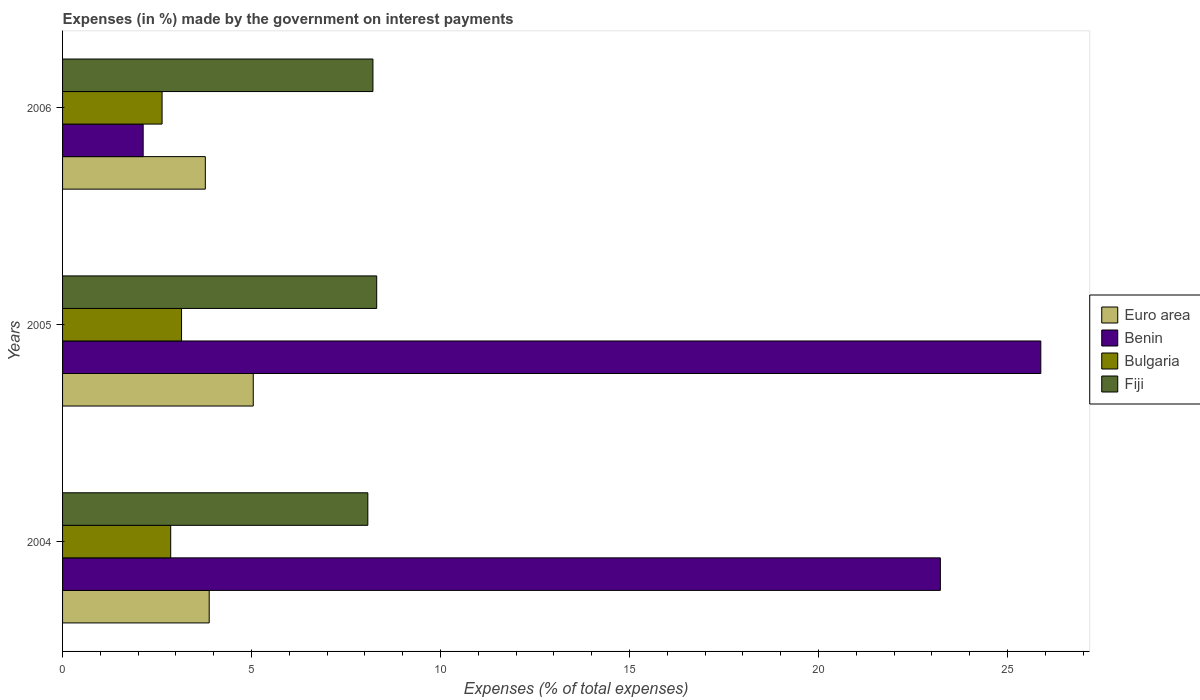How many different coloured bars are there?
Make the answer very short. 4. Are the number of bars per tick equal to the number of legend labels?
Give a very brief answer. Yes. Are the number of bars on each tick of the Y-axis equal?
Your answer should be very brief. Yes. In how many cases, is the number of bars for a given year not equal to the number of legend labels?
Make the answer very short. 0. What is the percentage of expenses made by the government on interest payments in Euro area in 2004?
Offer a terse response. 3.88. Across all years, what is the maximum percentage of expenses made by the government on interest payments in Benin?
Provide a short and direct response. 25.88. Across all years, what is the minimum percentage of expenses made by the government on interest payments in Fiji?
Offer a terse response. 8.08. What is the total percentage of expenses made by the government on interest payments in Bulgaria in the graph?
Keep it short and to the point. 8.64. What is the difference between the percentage of expenses made by the government on interest payments in Fiji in 2004 and that in 2005?
Provide a succinct answer. -0.23. What is the difference between the percentage of expenses made by the government on interest payments in Bulgaria in 2004 and the percentage of expenses made by the government on interest payments in Benin in 2006?
Provide a succinct answer. 0.73. What is the average percentage of expenses made by the government on interest payments in Euro area per year?
Your answer should be compact. 4.23. In the year 2005, what is the difference between the percentage of expenses made by the government on interest payments in Euro area and percentage of expenses made by the government on interest payments in Benin?
Make the answer very short. -20.84. In how many years, is the percentage of expenses made by the government on interest payments in Fiji greater than 4 %?
Offer a very short reply. 3. What is the ratio of the percentage of expenses made by the government on interest payments in Fiji in 2004 to that in 2005?
Provide a short and direct response. 0.97. Is the percentage of expenses made by the government on interest payments in Benin in 2005 less than that in 2006?
Ensure brevity in your answer.  No. What is the difference between the highest and the second highest percentage of expenses made by the government on interest payments in Fiji?
Make the answer very short. 0.1. What is the difference between the highest and the lowest percentage of expenses made by the government on interest payments in Euro area?
Your response must be concise. 1.27. In how many years, is the percentage of expenses made by the government on interest payments in Euro area greater than the average percentage of expenses made by the government on interest payments in Euro area taken over all years?
Provide a succinct answer. 1. Is the sum of the percentage of expenses made by the government on interest payments in Benin in 2005 and 2006 greater than the maximum percentage of expenses made by the government on interest payments in Euro area across all years?
Provide a short and direct response. Yes. Is it the case that in every year, the sum of the percentage of expenses made by the government on interest payments in Bulgaria and percentage of expenses made by the government on interest payments in Euro area is greater than the sum of percentage of expenses made by the government on interest payments in Fiji and percentage of expenses made by the government on interest payments in Benin?
Provide a short and direct response. No. What does the 1st bar from the top in 2004 represents?
Provide a succinct answer. Fiji. What does the 2nd bar from the bottom in 2004 represents?
Ensure brevity in your answer.  Benin. How many bars are there?
Your response must be concise. 12. Are all the bars in the graph horizontal?
Give a very brief answer. Yes. How many years are there in the graph?
Provide a succinct answer. 3. What is the difference between two consecutive major ticks on the X-axis?
Your response must be concise. 5. Does the graph contain any zero values?
Offer a terse response. No. Where does the legend appear in the graph?
Provide a succinct answer. Center right. How are the legend labels stacked?
Give a very brief answer. Vertical. What is the title of the graph?
Your answer should be very brief. Expenses (in %) made by the government on interest payments. What is the label or title of the X-axis?
Provide a succinct answer. Expenses (% of total expenses). What is the label or title of the Y-axis?
Provide a short and direct response. Years. What is the Expenses (% of total expenses) in Euro area in 2004?
Make the answer very short. 3.88. What is the Expenses (% of total expenses) in Benin in 2004?
Give a very brief answer. 23.22. What is the Expenses (% of total expenses) in Bulgaria in 2004?
Offer a terse response. 2.86. What is the Expenses (% of total expenses) in Fiji in 2004?
Your answer should be very brief. 8.08. What is the Expenses (% of total expenses) in Euro area in 2005?
Your answer should be very brief. 5.04. What is the Expenses (% of total expenses) of Benin in 2005?
Give a very brief answer. 25.88. What is the Expenses (% of total expenses) in Bulgaria in 2005?
Make the answer very short. 3.15. What is the Expenses (% of total expenses) of Fiji in 2005?
Provide a short and direct response. 8.31. What is the Expenses (% of total expenses) of Euro area in 2006?
Offer a very short reply. 3.78. What is the Expenses (% of total expenses) of Benin in 2006?
Your answer should be compact. 2.13. What is the Expenses (% of total expenses) of Bulgaria in 2006?
Offer a very short reply. 2.63. What is the Expenses (% of total expenses) in Fiji in 2006?
Your answer should be compact. 8.21. Across all years, what is the maximum Expenses (% of total expenses) of Euro area?
Give a very brief answer. 5.04. Across all years, what is the maximum Expenses (% of total expenses) in Benin?
Ensure brevity in your answer.  25.88. Across all years, what is the maximum Expenses (% of total expenses) of Bulgaria?
Offer a terse response. 3.15. Across all years, what is the maximum Expenses (% of total expenses) of Fiji?
Your answer should be compact. 8.31. Across all years, what is the minimum Expenses (% of total expenses) in Euro area?
Give a very brief answer. 3.78. Across all years, what is the minimum Expenses (% of total expenses) in Benin?
Your response must be concise. 2.13. Across all years, what is the minimum Expenses (% of total expenses) in Bulgaria?
Make the answer very short. 2.63. Across all years, what is the minimum Expenses (% of total expenses) of Fiji?
Offer a terse response. 8.08. What is the total Expenses (% of total expenses) in Euro area in the graph?
Your answer should be very brief. 12.7. What is the total Expenses (% of total expenses) of Benin in the graph?
Your answer should be very brief. 51.23. What is the total Expenses (% of total expenses) of Bulgaria in the graph?
Your answer should be compact. 8.64. What is the total Expenses (% of total expenses) in Fiji in the graph?
Provide a succinct answer. 24.6. What is the difference between the Expenses (% of total expenses) of Euro area in 2004 and that in 2005?
Provide a succinct answer. -1.17. What is the difference between the Expenses (% of total expenses) in Benin in 2004 and that in 2005?
Provide a succinct answer. -2.66. What is the difference between the Expenses (% of total expenses) in Bulgaria in 2004 and that in 2005?
Provide a short and direct response. -0.29. What is the difference between the Expenses (% of total expenses) in Fiji in 2004 and that in 2005?
Provide a short and direct response. -0.23. What is the difference between the Expenses (% of total expenses) of Euro area in 2004 and that in 2006?
Give a very brief answer. 0.1. What is the difference between the Expenses (% of total expenses) of Benin in 2004 and that in 2006?
Ensure brevity in your answer.  21.09. What is the difference between the Expenses (% of total expenses) of Bulgaria in 2004 and that in 2006?
Provide a short and direct response. 0.23. What is the difference between the Expenses (% of total expenses) of Fiji in 2004 and that in 2006?
Provide a succinct answer. -0.14. What is the difference between the Expenses (% of total expenses) of Euro area in 2005 and that in 2006?
Ensure brevity in your answer.  1.27. What is the difference between the Expenses (% of total expenses) of Benin in 2005 and that in 2006?
Offer a very short reply. 23.75. What is the difference between the Expenses (% of total expenses) of Bulgaria in 2005 and that in 2006?
Your response must be concise. 0.51. What is the difference between the Expenses (% of total expenses) of Fiji in 2005 and that in 2006?
Ensure brevity in your answer.  0.1. What is the difference between the Expenses (% of total expenses) of Euro area in 2004 and the Expenses (% of total expenses) of Benin in 2005?
Offer a very short reply. -22. What is the difference between the Expenses (% of total expenses) in Euro area in 2004 and the Expenses (% of total expenses) in Bulgaria in 2005?
Your response must be concise. 0.73. What is the difference between the Expenses (% of total expenses) in Euro area in 2004 and the Expenses (% of total expenses) in Fiji in 2005?
Make the answer very short. -4.43. What is the difference between the Expenses (% of total expenses) in Benin in 2004 and the Expenses (% of total expenses) in Bulgaria in 2005?
Offer a very short reply. 20.07. What is the difference between the Expenses (% of total expenses) of Benin in 2004 and the Expenses (% of total expenses) of Fiji in 2005?
Keep it short and to the point. 14.91. What is the difference between the Expenses (% of total expenses) in Bulgaria in 2004 and the Expenses (% of total expenses) in Fiji in 2005?
Offer a terse response. -5.45. What is the difference between the Expenses (% of total expenses) in Euro area in 2004 and the Expenses (% of total expenses) in Benin in 2006?
Provide a short and direct response. 1.75. What is the difference between the Expenses (% of total expenses) of Euro area in 2004 and the Expenses (% of total expenses) of Bulgaria in 2006?
Keep it short and to the point. 1.25. What is the difference between the Expenses (% of total expenses) in Euro area in 2004 and the Expenses (% of total expenses) in Fiji in 2006?
Offer a very short reply. -4.33. What is the difference between the Expenses (% of total expenses) of Benin in 2004 and the Expenses (% of total expenses) of Bulgaria in 2006?
Give a very brief answer. 20.59. What is the difference between the Expenses (% of total expenses) in Benin in 2004 and the Expenses (% of total expenses) in Fiji in 2006?
Offer a terse response. 15.01. What is the difference between the Expenses (% of total expenses) of Bulgaria in 2004 and the Expenses (% of total expenses) of Fiji in 2006?
Make the answer very short. -5.35. What is the difference between the Expenses (% of total expenses) of Euro area in 2005 and the Expenses (% of total expenses) of Benin in 2006?
Make the answer very short. 2.91. What is the difference between the Expenses (% of total expenses) in Euro area in 2005 and the Expenses (% of total expenses) in Bulgaria in 2006?
Your answer should be compact. 2.41. What is the difference between the Expenses (% of total expenses) in Euro area in 2005 and the Expenses (% of total expenses) in Fiji in 2006?
Keep it short and to the point. -3.17. What is the difference between the Expenses (% of total expenses) of Benin in 2005 and the Expenses (% of total expenses) of Bulgaria in 2006?
Keep it short and to the point. 23.25. What is the difference between the Expenses (% of total expenses) of Benin in 2005 and the Expenses (% of total expenses) of Fiji in 2006?
Your response must be concise. 17.67. What is the difference between the Expenses (% of total expenses) in Bulgaria in 2005 and the Expenses (% of total expenses) in Fiji in 2006?
Offer a very short reply. -5.06. What is the average Expenses (% of total expenses) of Euro area per year?
Your response must be concise. 4.23. What is the average Expenses (% of total expenses) of Benin per year?
Give a very brief answer. 17.08. What is the average Expenses (% of total expenses) of Bulgaria per year?
Offer a very short reply. 2.88. What is the average Expenses (% of total expenses) in Fiji per year?
Provide a succinct answer. 8.2. In the year 2004, what is the difference between the Expenses (% of total expenses) of Euro area and Expenses (% of total expenses) of Benin?
Your response must be concise. -19.34. In the year 2004, what is the difference between the Expenses (% of total expenses) of Euro area and Expenses (% of total expenses) of Bulgaria?
Provide a short and direct response. 1.02. In the year 2004, what is the difference between the Expenses (% of total expenses) in Euro area and Expenses (% of total expenses) in Fiji?
Your answer should be very brief. -4.2. In the year 2004, what is the difference between the Expenses (% of total expenses) in Benin and Expenses (% of total expenses) in Bulgaria?
Your response must be concise. 20.36. In the year 2004, what is the difference between the Expenses (% of total expenses) in Benin and Expenses (% of total expenses) in Fiji?
Offer a very short reply. 15.15. In the year 2004, what is the difference between the Expenses (% of total expenses) in Bulgaria and Expenses (% of total expenses) in Fiji?
Your answer should be very brief. -5.21. In the year 2005, what is the difference between the Expenses (% of total expenses) in Euro area and Expenses (% of total expenses) in Benin?
Your answer should be very brief. -20.84. In the year 2005, what is the difference between the Expenses (% of total expenses) of Euro area and Expenses (% of total expenses) of Bulgaria?
Make the answer very short. 1.9. In the year 2005, what is the difference between the Expenses (% of total expenses) in Euro area and Expenses (% of total expenses) in Fiji?
Offer a very short reply. -3.27. In the year 2005, what is the difference between the Expenses (% of total expenses) of Benin and Expenses (% of total expenses) of Bulgaria?
Make the answer very short. 22.73. In the year 2005, what is the difference between the Expenses (% of total expenses) in Benin and Expenses (% of total expenses) in Fiji?
Make the answer very short. 17.57. In the year 2005, what is the difference between the Expenses (% of total expenses) in Bulgaria and Expenses (% of total expenses) in Fiji?
Offer a terse response. -5.16. In the year 2006, what is the difference between the Expenses (% of total expenses) in Euro area and Expenses (% of total expenses) in Benin?
Provide a short and direct response. 1.64. In the year 2006, what is the difference between the Expenses (% of total expenses) in Euro area and Expenses (% of total expenses) in Bulgaria?
Keep it short and to the point. 1.14. In the year 2006, what is the difference between the Expenses (% of total expenses) in Euro area and Expenses (% of total expenses) in Fiji?
Offer a very short reply. -4.43. In the year 2006, what is the difference between the Expenses (% of total expenses) in Benin and Expenses (% of total expenses) in Bulgaria?
Provide a short and direct response. -0.5. In the year 2006, what is the difference between the Expenses (% of total expenses) of Benin and Expenses (% of total expenses) of Fiji?
Provide a succinct answer. -6.08. In the year 2006, what is the difference between the Expenses (% of total expenses) of Bulgaria and Expenses (% of total expenses) of Fiji?
Ensure brevity in your answer.  -5.58. What is the ratio of the Expenses (% of total expenses) in Euro area in 2004 to that in 2005?
Make the answer very short. 0.77. What is the ratio of the Expenses (% of total expenses) of Benin in 2004 to that in 2005?
Make the answer very short. 0.9. What is the ratio of the Expenses (% of total expenses) in Bulgaria in 2004 to that in 2005?
Provide a short and direct response. 0.91. What is the ratio of the Expenses (% of total expenses) of Fiji in 2004 to that in 2005?
Provide a short and direct response. 0.97. What is the ratio of the Expenses (% of total expenses) in Euro area in 2004 to that in 2006?
Give a very brief answer. 1.03. What is the ratio of the Expenses (% of total expenses) in Benin in 2004 to that in 2006?
Provide a short and direct response. 10.89. What is the ratio of the Expenses (% of total expenses) in Bulgaria in 2004 to that in 2006?
Your answer should be very brief. 1.09. What is the ratio of the Expenses (% of total expenses) in Fiji in 2004 to that in 2006?
Your answer should be compact. 0.98. What is the ratio of the Expenses (% of total expenses) of Euro area in 2005 to that in 2006?
Your response must be concise. 1.34. What is the ratio of the Expenses (% of total expenses) of Benin in 2005 to that in 2006?
Offer a very short reply. 12.14. What is the ratio of the Expenses (% of total expenses) of Bulgaria in 2005 to that in 2006?
Your response must be concise. 1.2. What is the ratio of the Expenses (% of total expenses) in Fiji in 2005 to that in 2006?
Your answer should be compact. 1.01. What is the difference between the highest and the second highest Expenses (% of total expenses) in Euro area?
Ensure brevity in your answer.  1.17. What is the difference between the highest and the second highest Expenses (% of total expenses) in Benin?
Offer a very short reply. 2.66. What is the difference between the highest and the second highest Expenses (% of total expenses) of Bulgaria?
Make the answer very short. 0.29. What is the difference between the highest and the second highest Expenses (% of total expenses) in Fiji?
Provide a succinct answer. 0.1. What is the difference between the highest and the lowest Expenses (% of total expenses) in Euro area?
Offer a terse response. 1.27. What is the difference between the highest and the lowest Expenses (% of total expenses) in Benin?
Offer a very short reply. 23.75. What is the difference between the highest and the lowest Expenses (% of total expenses) in Bulgaria?
Provide a short and direct response. 0.51. What is the difference between the highest and the lowest Expenses (% of total expenses) of Fiji?
Provide a succinct answer. 0.23. 